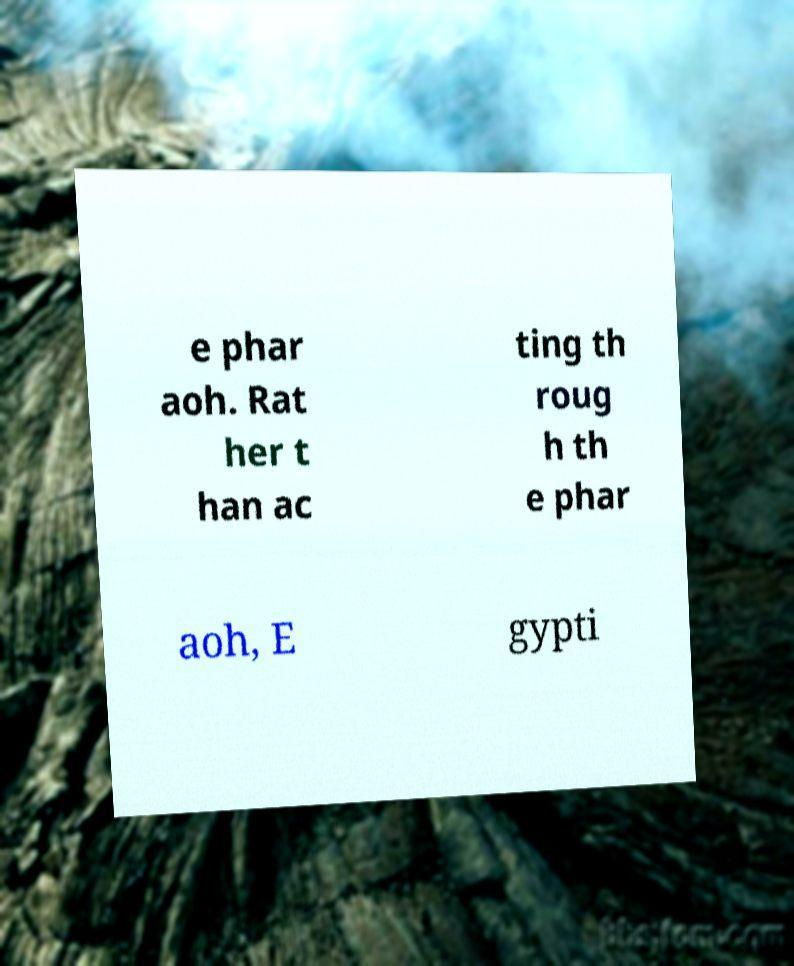I need the written content from this picture converted into text. Can you do that? e phar aoh. Rat her t han ac ting th roug h th e phar aoh, E gypti 